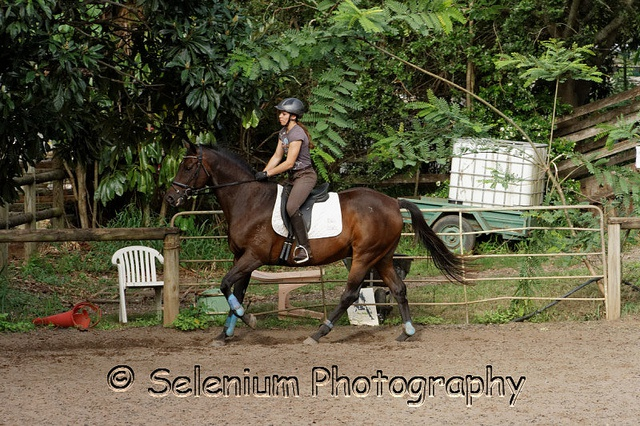Describe the objects in this image and their specific colors. I can see horse in darkgreen, black, maroon, and gray tones, people in darkgreen, gray, black, and tan tones, and chair in darkgreen, lightgray, black, gray, and darkgray tones in this image. 